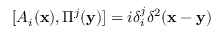Convert formula to latex. <formula><loc_0><loc_0><loc_500><loc_500>[ A _ { i } ( { x } ) , \Pi ^ { j } ( { y } ) ] = i \delta _ { i } ^ { j } \delta ^ { 2 } ( { x } - { y } )</formula> 